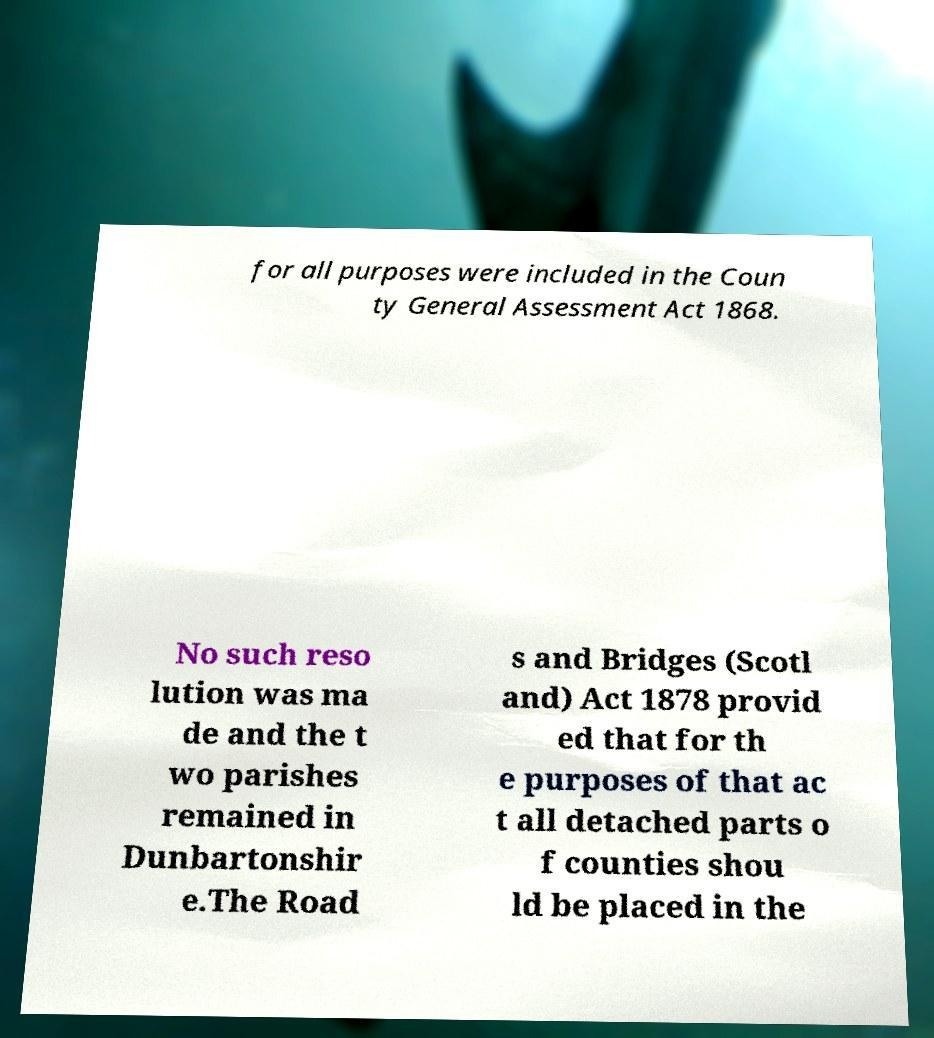There's text embedded in this image that I need extracted. Can you transcribe it verbatim? for all purposes were included in the Coun ty General Assessment Act 1868. No such reso lution was ma de and the t wo parishes remained in Dunbartonshir e.The Road s and Bridges (Scotl and) Act 1878 provid ed that for th e purposes of that ac t all detached parts o f counties shou ld be placed in the 